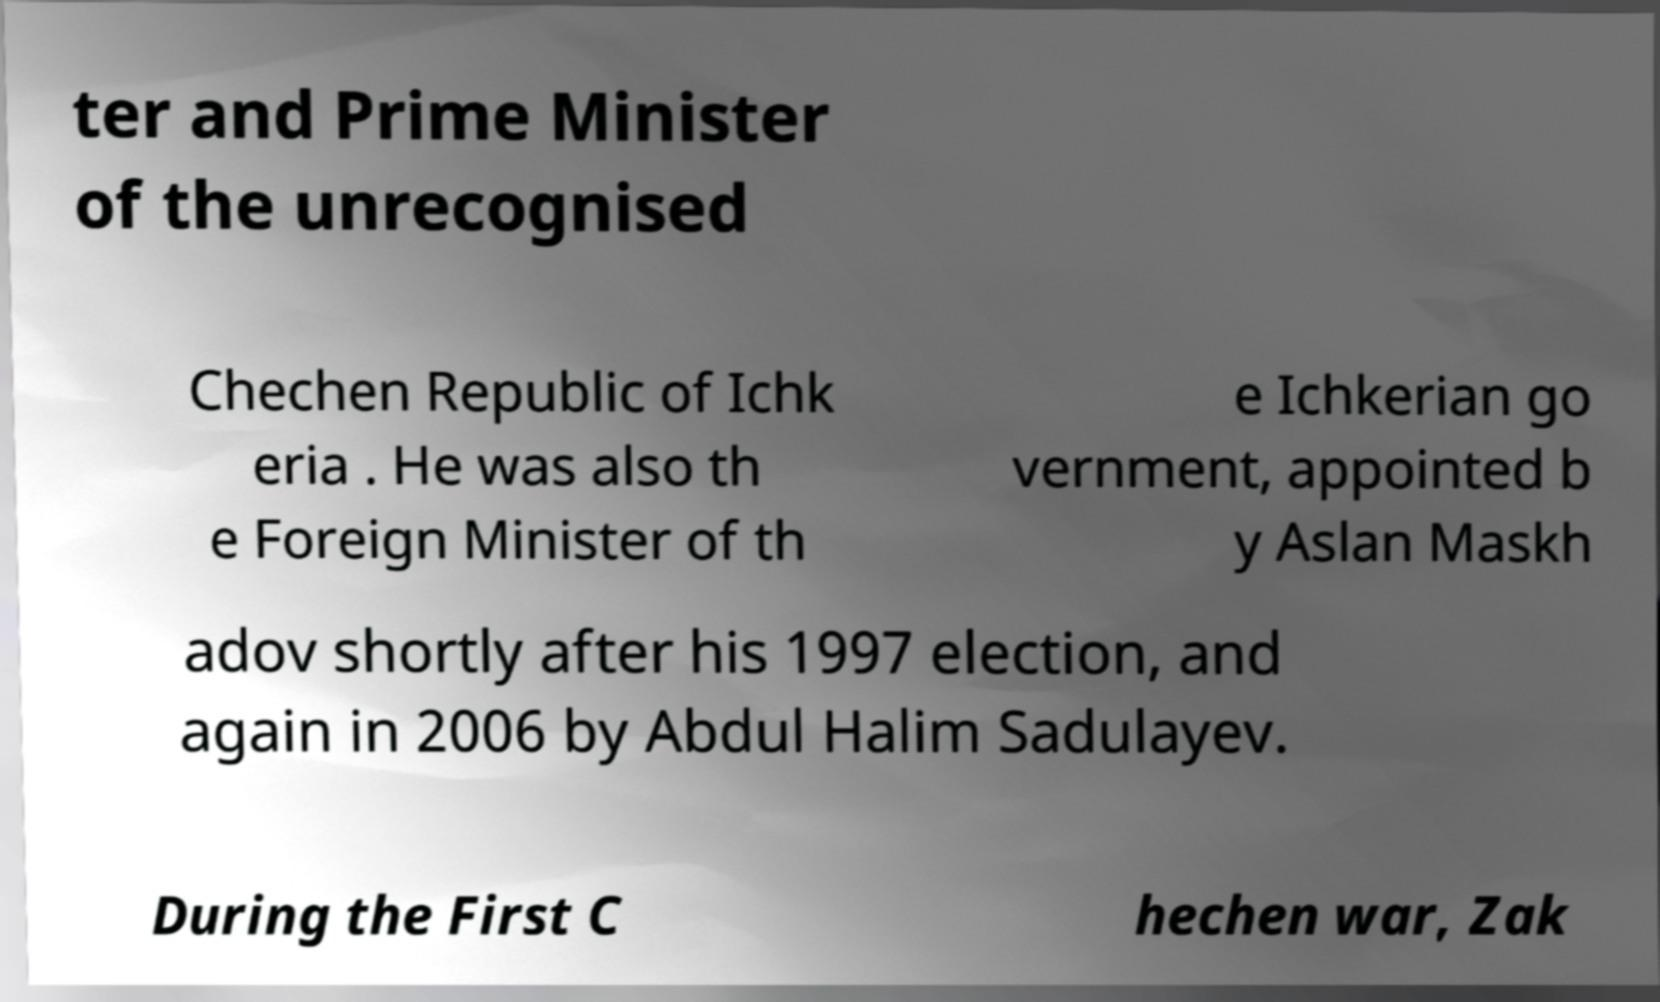Can you read and provide the text displayed in the image?This photo seems to have some interesting text. Can you extract and type it out for me? ter and Prime Minister of the unrecognised Chechen Republic of Ichk eria . He was also th e Foreign Minister of th e Ichkerian go vernment, appointed b y Aslan Maskh adov shortly after his 1997 election, and again in 2006 by Abdul Halim Sadulayev. During the First C hechen war, Zak 